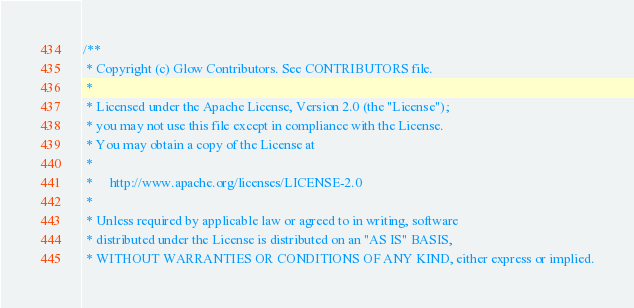Convert code to text. <code><loc_0><loc_0><loc_500><loc_500><_C++_>/**
 * Copyright (c) Glow Contributors. See CONTRIBUTORS file.
 *
 * Licensed under the Apache License, Version 2.0 (the "License");
 * you may not use this file except in compliance with the License.
 * You may obtain a copy of the License at
 *
 *     http://www.apache.org/licenses/LICENSE-2.0
 *
 * Unless required by applicable law or agreed to in writing, software
 * distributed under the License is distributed on an "AS IS" BASIS,
 * WITHOUT WARRANTIES OR CONDITIONS OF ANY KIND, either express or implied.</code> 